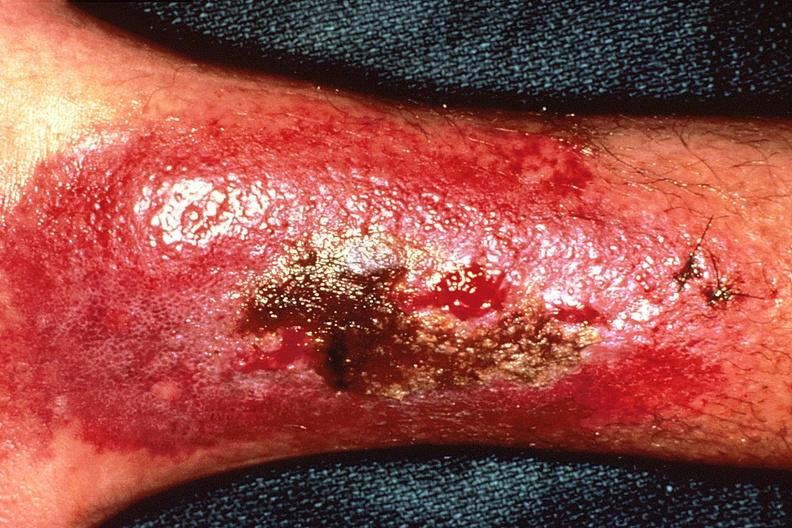does glioma show bacterial dematitis at site of skin biopsy?
Answer the question using a single word or phrase. No 